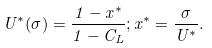Convert formula to latex. <formula><loc_0><loc_0><loc_500><loc_500>U ^ { * } ( \sigma ) = \frac { 1 - x ^ { * } } { 1 - C _ { L } } ; x ^ { * } = \frac { \sigma } { U ^ { * } } .</formula> 